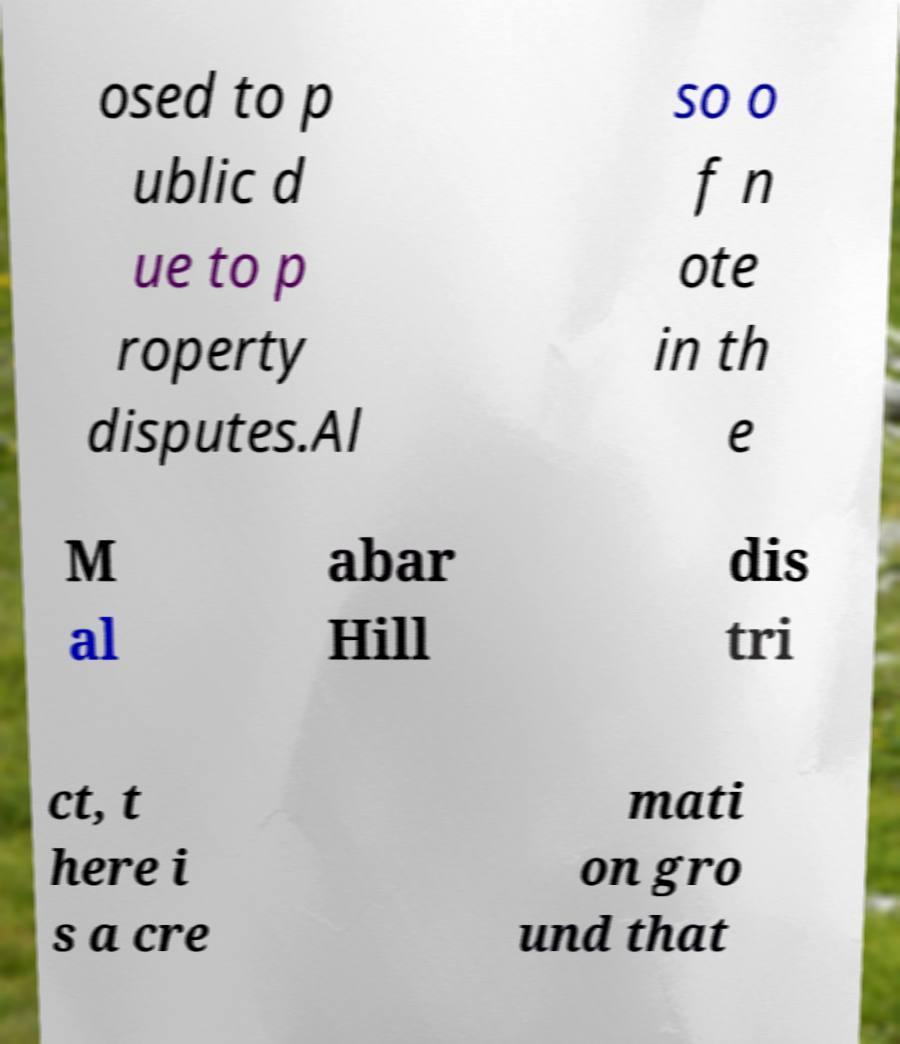There's text embedded in this image that I need extracted. Can you transcribe it verbatim? osed to p ublic d ue to p roperty disputes.Al so o f n ote in th e M al abar Hill dis tri ct, t here i s a cre mati on gro und that 